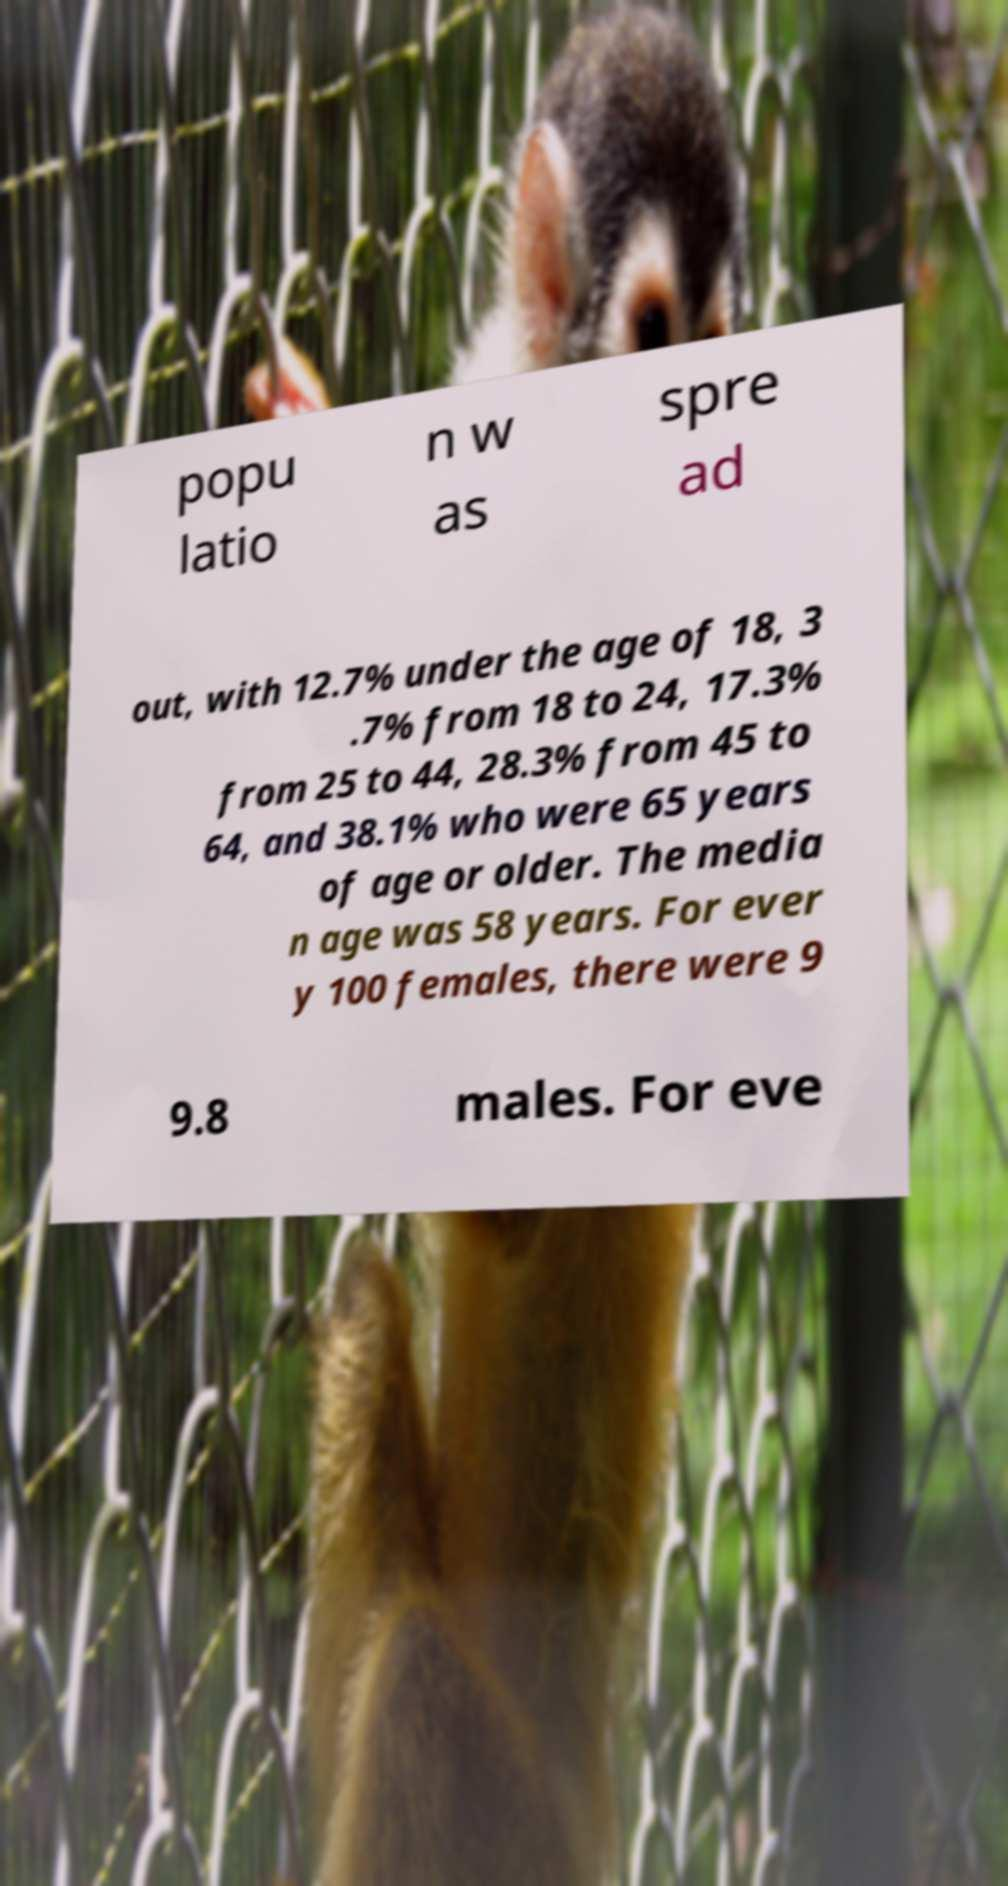Please read and relay the text visible in this image. What does it say? popu latio n w as spre ad out, with 12.7% under the age of 18, 3 .7% from 18 to 24, 17.3% from 25 to 44, 28.3% from 45 to 64, and 38.1% who were 65 years of age or older. The media n age was 58 years. For ever y 100 females, there were 9 9.8 males. For eve 